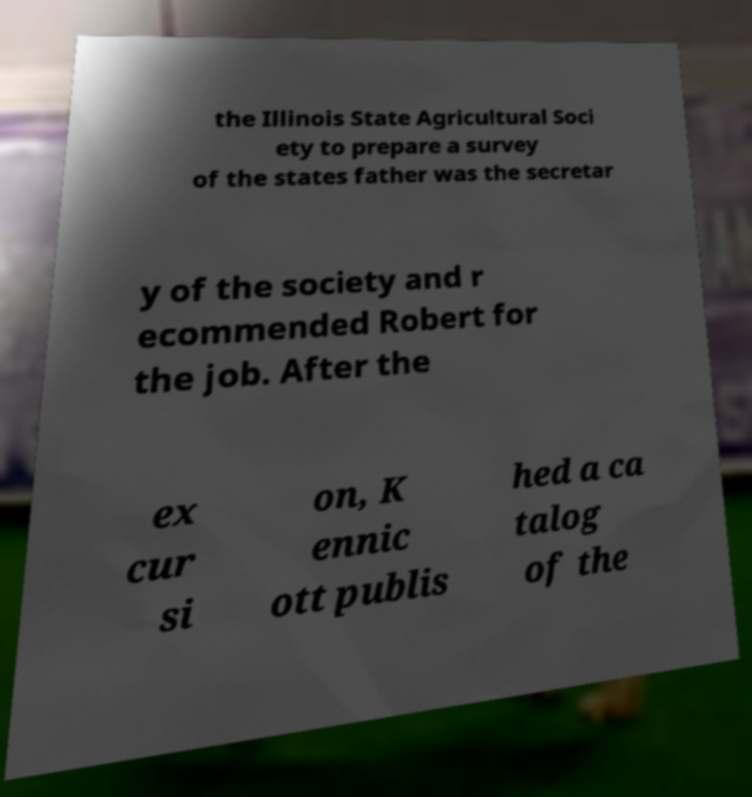Can you accurately transcribe the text from the provided image for me? the Illinois State Agricultural Soci ety to prepare a survey of the states father was the secretar y of the society and r ecommended Robert for the job. After the ex cur si on, K ennic ott publis hed a ca talog of the 